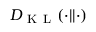<formula> <loc_0><loc_0><loc_500><loc_500>D _ { K L } ( \cdot | | \cdot )</formula> 